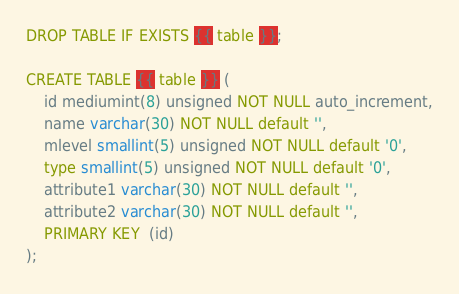Convert code to text. <code><loc_0><loc_0><loc_500><loc_500><_SQL_>DROP TABLE IF EXISTS {{ table }};

CREATE TABLE {{ table }} (
    id mediumint(8) unsigned NOT NULL auto_increment,
    name varchar(30) NOT NULL default '',
    mlevel smallint(5) unsigned NOT NULL default '0',
    type smallint(5) unsigned NOT NULL default '0',
    attribute1 varchar(30) NOT NULL default '',
    attribute2 varchar(30) NOT NULL default '',
    PRIMARY KEY  (id)
);</code> 